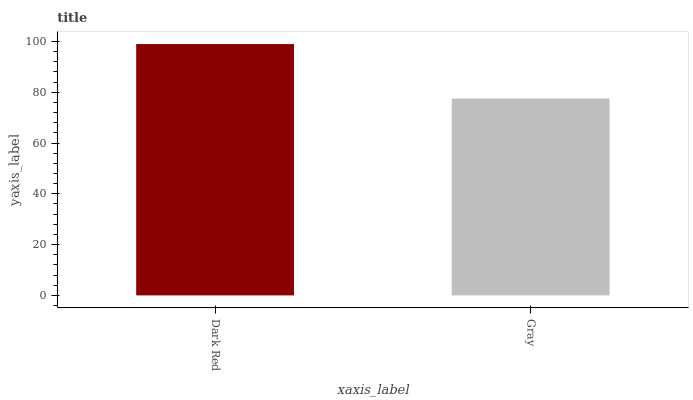Is Gray the minimum?
Answer yes or no. Yes. Is Dark Red the maximum?
Answer yes or no. Yes. Is Gray the maximum?
Answer yes or no. No. Is Dark Red greater than Gray?
Answer yes or no. Yes. Is Gray less than Dark Red?
Answer yes or no. Yes. Is Gray greater than Dark Red?
Answer yes or no. No. Is Dark Red less than Gray?
Answer yes or no. No. Is Dark Red the high median?
Answer yes or no. Yes. Is Gray the low median?
Answer yes or no. Yes. Is Gray the high median?
Answer yes or no. No. Is Dark Red the low median?
Answer yes or no. No. 